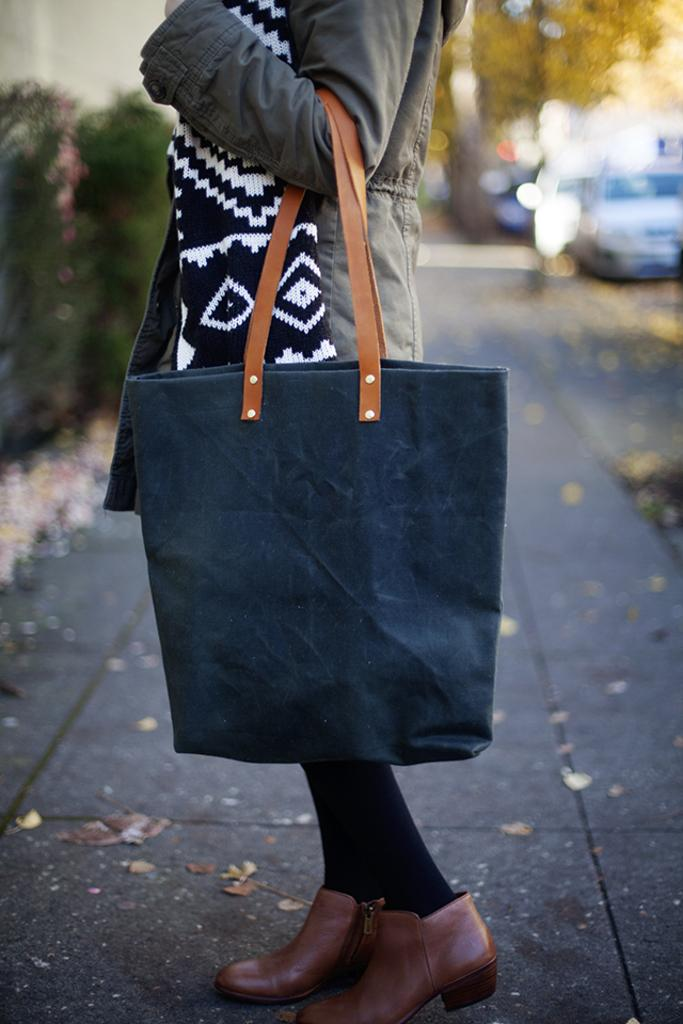What type of clothing is the woman wearing around her neck in the image? The woman is wearing a scarf in the image. What type of outerwear is the woman wearing? The woman is wearing a jacket in the image. What color is the handbag the woman is holding? The woman is holding a blue handbag in the image. What type of natural elements can be seen in the background of the image? There are trees and plants in the background of the image. What type of man-made object can be seen in the background of the image? There is a vehicle visible on the road in the background of the image. What type of jewel can be seen sparkling on the woman's hand in the image? There is no jewel visible on the woman's hand in the image. How does the steam from the vehicle in the background affect the visibility of the woman in the image? There is no steam visible in the image, so it does not affect the visibility of the woman. 